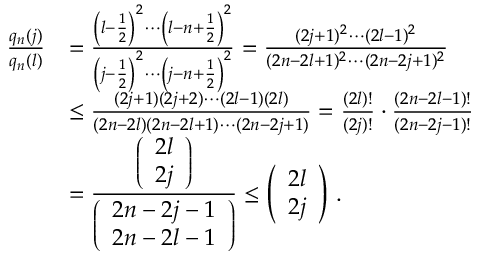<formula> <loc_0><loc_0><loc_500><loc_500>\begin{array} { r l } { \frac { q _ { n } ( j ) } { q _ { n } ( l ) } } & { = \frac { \left ( l - \frac { 1 } { 2 } \right ) ^ { 2 } \cdots \left ( l - n + \frac { 1 } { 2 } \right ) ^ { 2 } } { \left ( j - \frac { 1 } { 2 } \right ) ^ { 2 } \cdots \left ( j - n + \frac { 1 } { 2 } \right ) ^ { 2 } } = \frac { ( 2 j + 1 ) ^ { 2 } \cdots ( 2 l - 1 ) ^ { 2 } } { ( 2 n - 2 l + 1 ) ^ { 2 } \cdots ( 2 n - 2 j + 1 ) ^ { 2 } } } \\ & { \leq \frac { ( 2 j + 1 ) ( 2 j + 2 ) \cdots ( 2 l - 1 ) ( 2 l ) } { ( 2 n - 2 l ) ( 2 n - 2 l + 1 ) \cdots ( 2 n - 2 j + 1 ) } = \frac { ( 2 l ) ! } { ( 2 j ) ! } \cdot \frac { ( 2 n - 2 l - 1 ) ! } { ( 2 n - 2 j - 1 ) ! } } \\ & { = \frac { \left ( \begin{array} { c } { 2 l } \\ { 2 j } \end{array} \right ) } { \left ( \begin{array} { c } { 2 n - 2 j - 1 } \\ { 2 n - 2 l - 1 } \end{array} \right ) } \leq \left ( \begin{array} { c } { 2 l } \\ { 2 j } \end{array} \right ) \, . } \end{array}</formula> 